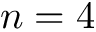<formula> <loc_0><loc_0><loc_500><loc_500>n = 4</formula> 